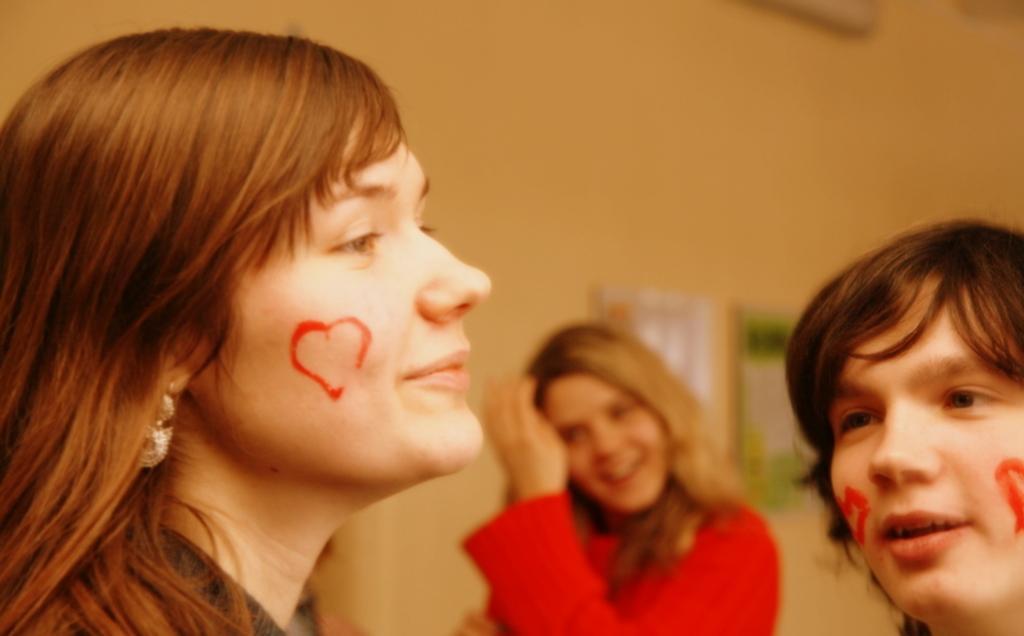Can you describe this image briefly? In this picture I can see few people standing and I can see painting on two people's faces and I can see a wall. 